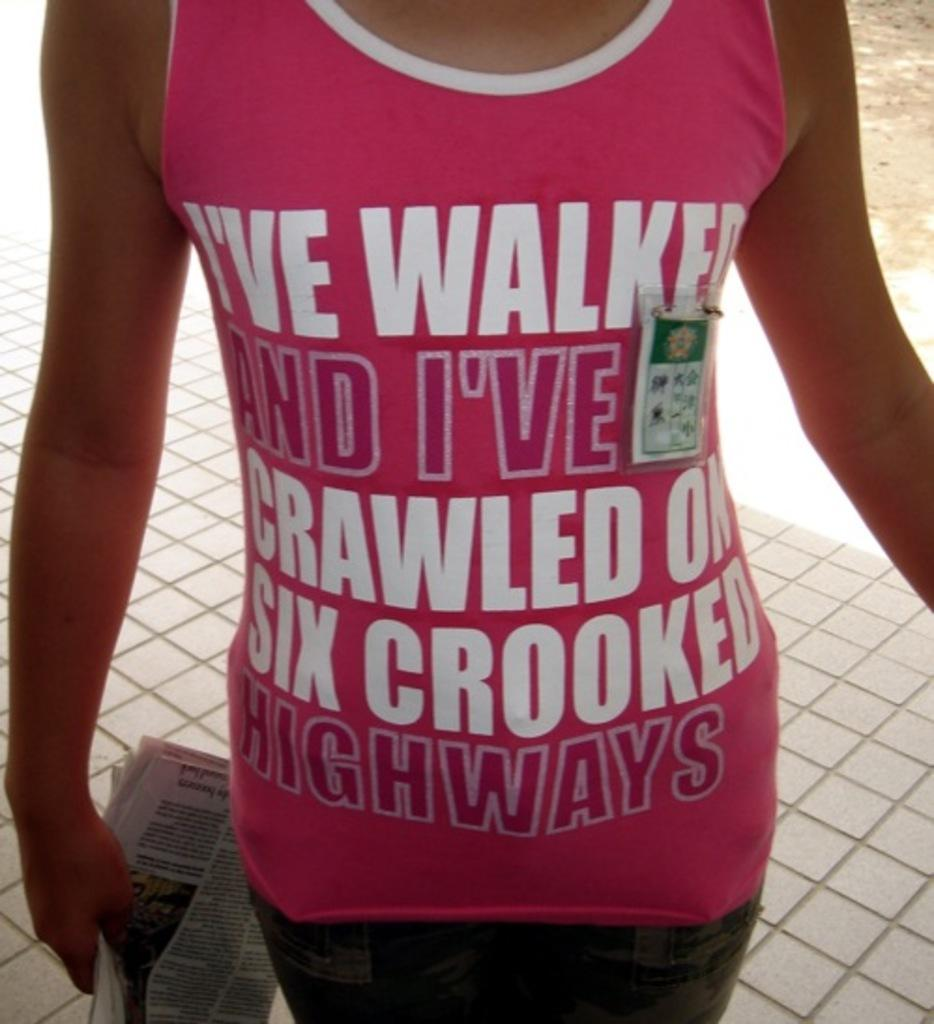What is the main subject of the image? There is a person in the image. What is the person wearing? The person is wearing a pink dress. Can you describe the pink dress further? The pink dress has writing on it. What else is the person wearing? The person is wearing a badge. What is the person holding in the image? The person is holding a newspaper. What can be seen in the background of the image? There is a floor visible in the background of the image. How many cows are visible in the image? There are no cows present in the image. What type of jam is being spread on the edge of the newspaper? There is no jam or spreading activity visible in the image. 